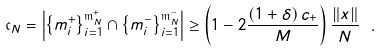<formula> <loc_0><loc_0><loc_500><loc_500>\mathfrak { c } _ { N } = \left | \left \{ m _ { i } ^ { + } \right \} _ { i = 1 } ^ { \mathfrak { m } _ { N } ^ { + } } \cap \left \{ m _ { i } ^ { - } \right \} _ { i = 1 } ^ { \mathfrak { m } _ { N } ^ { - } } \right | \geq \left ( 1 - 2 \frac { \left ( 1 + \delta \right ) c _ { + } } { M } \right ) \frac { \left \| x \right \| } { N } \ .</formula> 